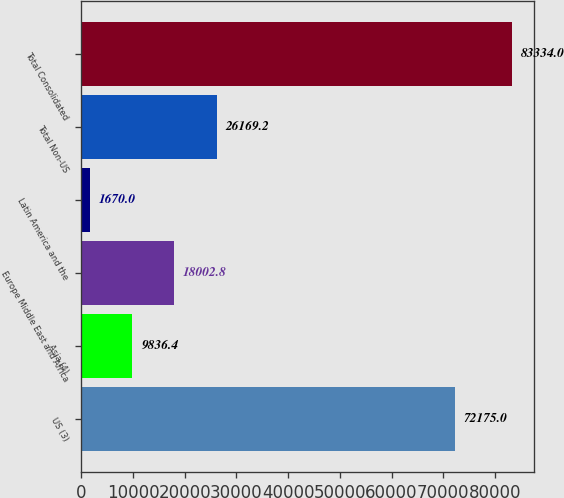<chart> <loc_0><loc_0><loc_500><loc_500><bar_chart><fcel>US (3)<fcel>Asia (4)<fcel>Europe Middle East and Africa<fcel>Latin America and the<fcel>Total Non-US<fcel>Total Consolidated<nl><fcel>72175<fcel>9836.4<fcel>18002.8<fcel>1670<fcel>26169.2<fcel>83334<nl></chart> 